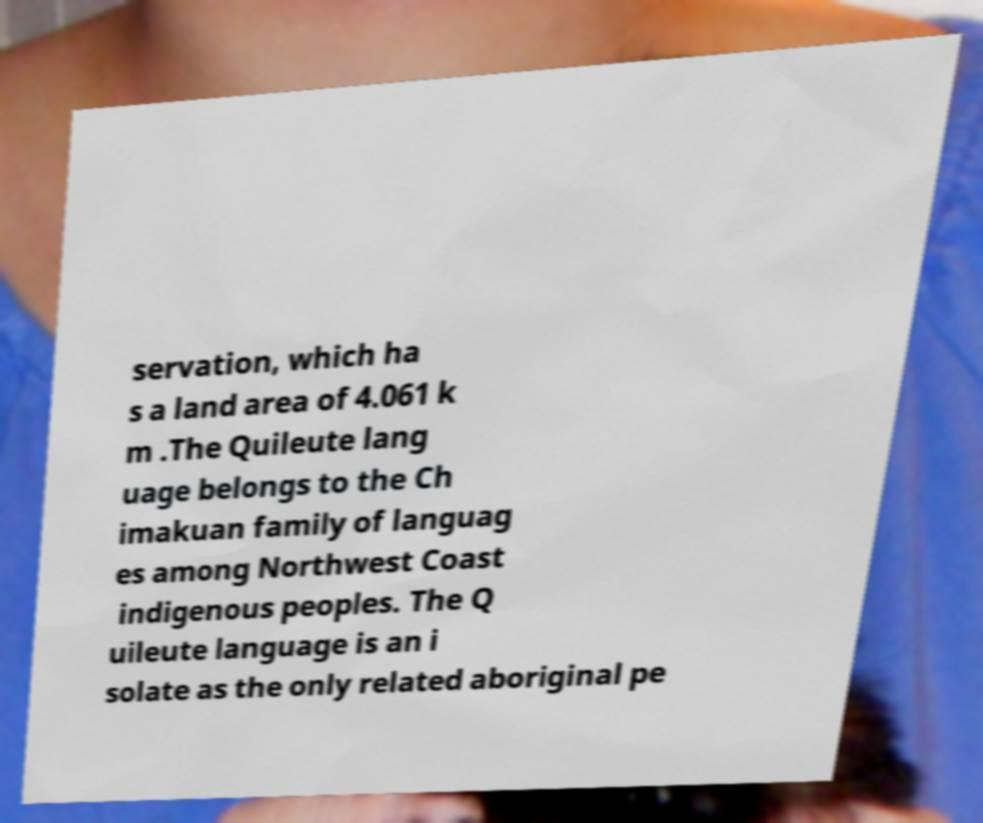Could you extract and type out the text from this image? servation, which ha s a land area of 4.061 k m .The Quileute lang uage belongs to the Ch imakuan family of languag es among Northwest Coast indigenous peoples. The Q uileute language is an i solate as the only related aboriginal pe 